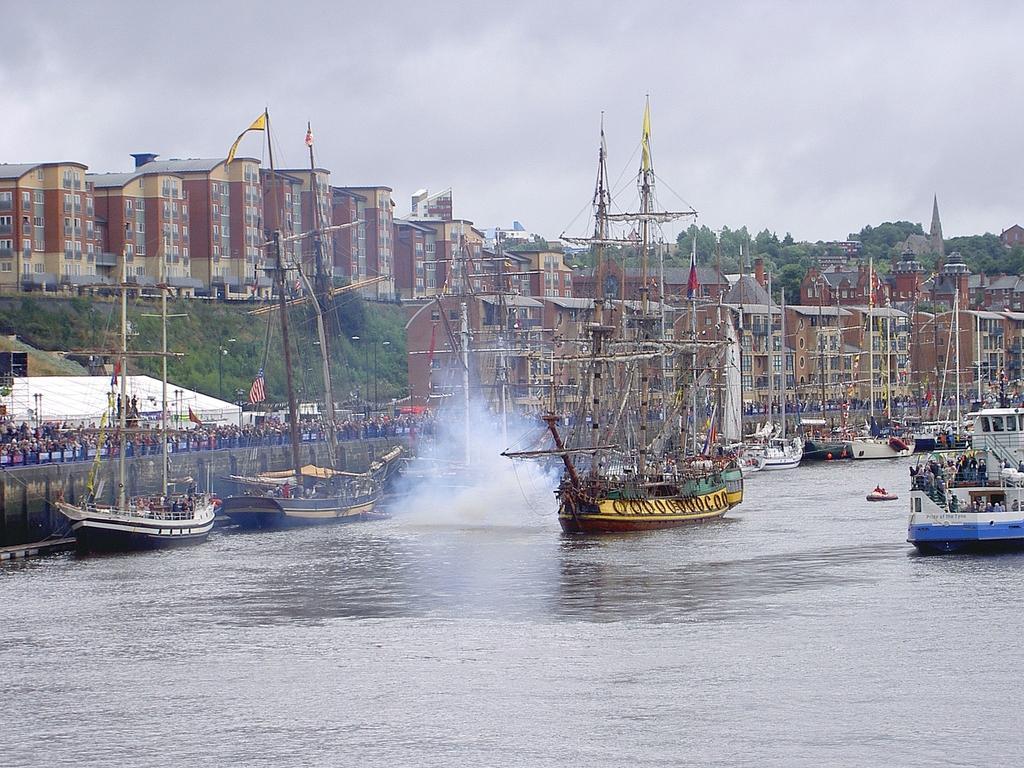Could you give a brief overview of what you see in this image? In this image we can see the buildings, trees, flags, poles and also the boats on the surface of the water. We can also see the wall, people and also the cloudy sky. 